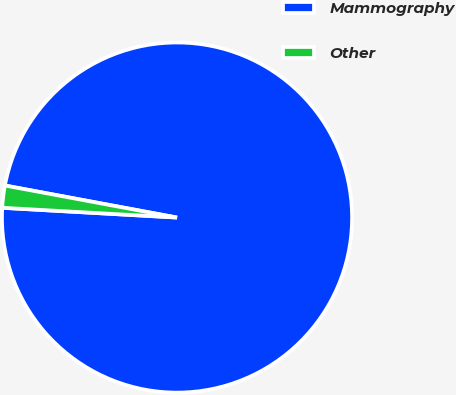Convert chart to OTSL. <chart><loc_0><loc_0><loc_500><loc_500><pie_chart><fcel>Mammography<fcel>Other<nl><fcel>97.96%<fcel>2.04%<nl></chart> 